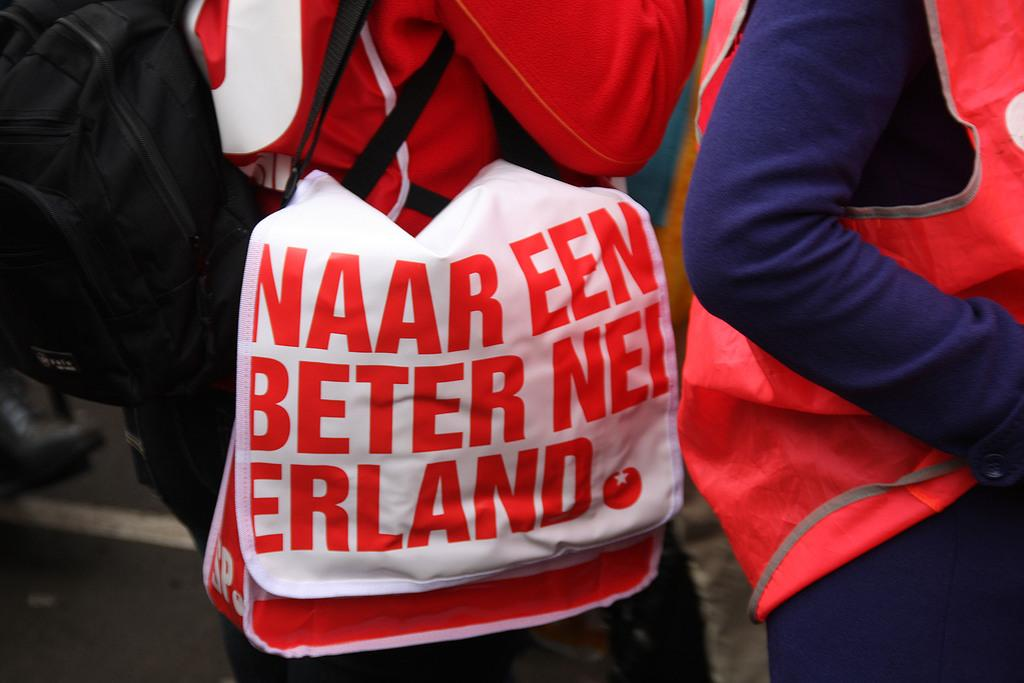Provide a one-sentence caption for the provided image. Person is holding a bag that have naar een beter nei erland wrote on it. 